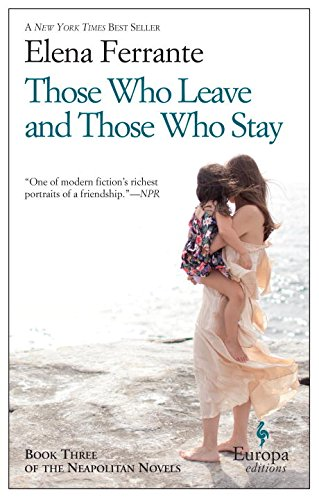Can you describe the primary theme of this book? The primary theme revolves around the enduring and evolving friendship between two women, Lila and Elena, as they navigate the complexities of life, ambition, and societal expectations in mid-20th-century Naples. 